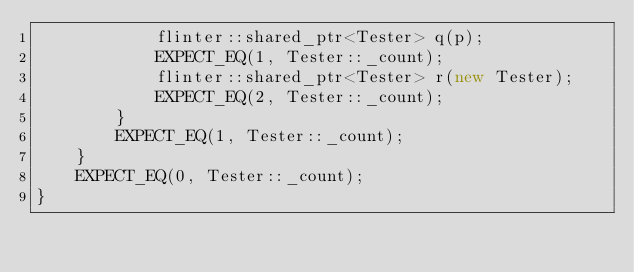<code> <loc_0><loc_0><loc_500><loc_500><_C++_>            flinter::shared_ptr<Tester> q(p);
            EXPECT_EQ(1, Tester::_count);
            flinter::shared_ptr<Tester> r(new Tester);
            EXPECT_EQ(2, Tester::_count);
        }
        EXPECT_EQ(1, Tester::_count);
    }
    EXPECT_EQ(0, Tester::_count);
}
</code> 